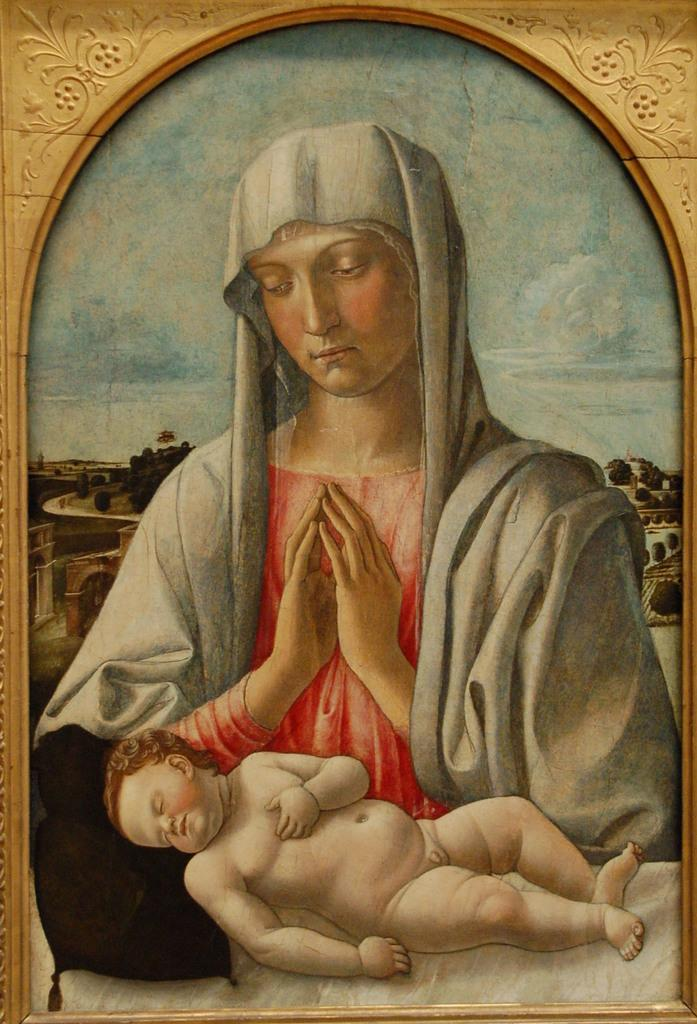What object is present in the image that typically holds a picture? There is a photo frame in the image. What can be seen inside the photo frame? The photo frame contains a picture of a woman and a baby. What type of environment is visible in the background of the image? There are trees and buildings in the background of the image. What type of oatmeal is being exchanged between the woman and the baby in the image? There is no oatmeal or exchange of any kind depicted in the image; it features a photo frame with a picture of a woman and a baby. What is the texture of the baby's clothing in the image? The image is not detailed enough to determine the texture of the baby's clothing. 